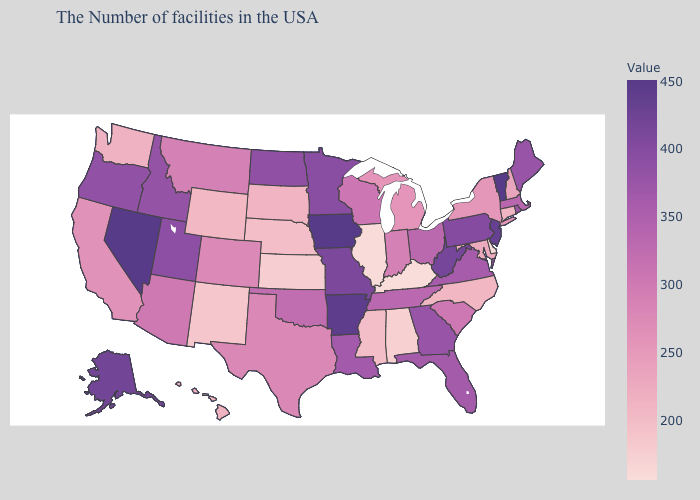Does New Jersey have the highest value in the Northeast?
Be succinct. No. Among the states that border Utah , does New Mexico have the lowest value?
Write a very short answer. Yes. Among the states that border Arkansas , does Missouri have the lowest value?
Keep it brief. No. Is the legend a continuous bar?
Write a very short answer. Yes. Does the map have missing data?
Short answer required. No. Does Hawaii have a lower value than Florida?
Give a very brief answer. Yes. Does the map have missing data?
Keep it brief. No. Among the states that border Wisconsin , which have the lowest value?
Write a very short answer. Illinois. Which states have the lowest value in the West?
Keep it brief. New Mexico. Is the legend a continuous bar?
Be succinct. Yes. Among the states that border Oregon , does Washington have the lowest value?
Write a very short answer. Yes. 